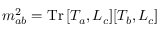Convert formula to latex. <formula><loc_0><loc_0><loc_500><loc_500>m _ { a b } ^ { 2 } = T r \, [ T _ { a } , L _ { c } ] [ T _ { b } , L _ { c } ]</formula> 